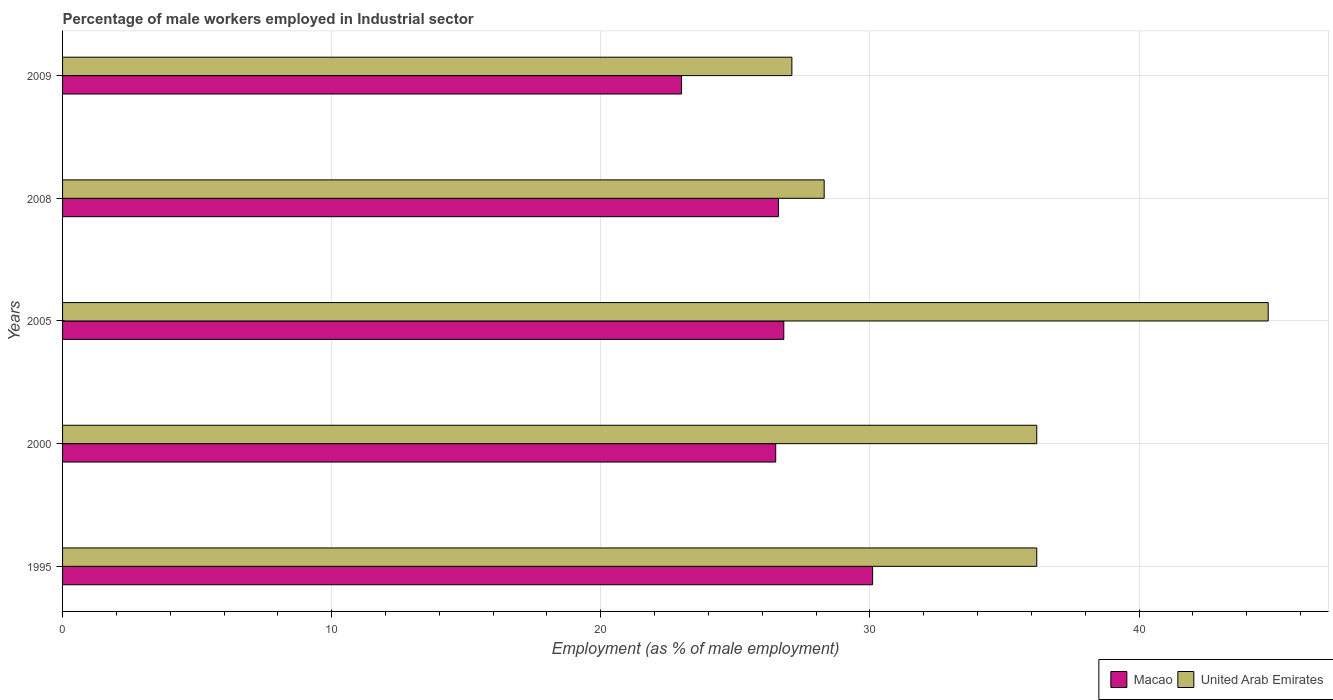How many different coloured bars are there?
Give a very brief answer. 2. How many bars are there on the 1st tick from the bottom?
Offer a very short reply. 2. What is the percentage of male workers employed in Industrial sector in United Arab Emirates in 2000?
Provide a succinct answer. 36.2. Across all years, what is the maximum percentage of male workers employed in Industrial sector in United Arab Emirates?
Keep it short and to the point. 44.8. Across all years, what is the minimum percentage of male workers employed in Industrial sector in Macao?
Your answer should be very brief. 23. In which year was the percentage of male workers employed in Industrial sector in United Arab Emirates maximum?
Offer a terse response. 2005. In which year was the percentage of male workers employed in Industrial sector in United Arab Emirates minimum?
Your answer should be compact. 2009. What is the total percentage of male workers employed in Industrial sector in Macao in the graph?
Offer a terse response. 133. What is the difference between the percentage of male workers employed in Industrial sector in Macao in 2005 and that in 2008?
Provide a short and direct response. 0.2. What is the difference between the percentage of male workers employed in Industrial sector in Macao in 2000 and the percentage of male workers employed in Industrial sector in United Arab Emirates in 2008?
Provide a short and direct response. -1.8. What is the average percentage of male workers employed in Industrial sector in United Arab Emirates per year?
Your answer should be compact. 34.52. In the year 1995, what is the difference between the percentage of male workers employed in Industrial sector in United Arab Emirates and percentage of male workers employed in Industrial sector in Macao?
Offer a very short reply. 6.1. What is the ratio of the percentage of male workers employed in Industrial sector in Macao in 2008 to that in 2009?
Make the answer very short. 1.16. Is the difference between the percentage of male workers employed in Industrial sector in United Arab Emirates in 1995 and 2005 greater than the difference between the percentage of male workers employed in Industrial sector in Macao in 1995 and 2005?
Give a very brief answer. No. What is the difference between the highest and the second highest percentage of male workers employed in Industrial sector in Macao?
Offer a very short reply. 3.3. What is the difference between the highest and the lowest percentage of male workers employed in Industrial sector in United Arab Emirates?
Give a very brief answer. 17.7. In how many years, is the percentage of male workers employed in Industrial sector in United Arab Emirates greater than the average percentage of male workers employed in Industrial sector in United Arab Emirates taken over all years?
Your answer should be very brief. 3. Is the sum of the percentage of male workers employed in Industrial sector in United Arab Emirates in 1995 and 2008 greater than the maximum percentage of male workers employed in Industrial sector in Macao across all years?
Provide a succinct answer. Yes. What does the 2nd bar from the top in 2005 represents?
Offer a terse response. Macao. What does the 1st bar from the bottom in 2000 represents?
Your response must be concise. Macao. How many years are there in the graph?
Give a very brief answer. 5. Are the values on the major ticks of X-axis written in scientific E-notation?
Your response must be concise. No. Does the graph contain grids?
Give a very brief answer. Yes. Where does the legend appear in the graph?
Give a very brief answer. Bottom right. How many legend labels are there?
Give a very brief answer. 2. What is the title of the graph?
Offer a very short reply. Percentage of male workers employed in Industrial sector. Does "Haiti" appear as one of the legend labels in the graph?
Give a very brief answer. No. What is the label or title of the X-axis?
Keep it short and to the point. Employment (as % of male employment). What is the label or title of the Y-axis?
Your answer should be very brief. Years. What is the Employment (as % of male employment) of Macao in 1995?
Offer a terse response. 30.1. What is the Employment (as % of male employment) in United Arab Emirates in 1995?
Keep it short and to the point. 36.2. What is the Employment (as % of male employment) in Macao in 2000?
Your answer should be very brief. 26.5. What is the Employment (as % of male employment) of United Arab Emirates in 2000?
Make the answer very short. 36.2. What is the Employment (as % of male employment) of Macao in 2005?
Provide a succinct answer. 26.8. What is the Employment (as % of male employment) in United Arab Emirates in 2005?
Your answer should be very brief. 44.8. What is the Employment (as % of male employment) in Macao in 2008?
Give a very brief answer. 26.6. What is the Employment (as % of male employment) in United Arab Emirates in 2008?
Your answer should be very brief. 28.3. What is the Employment (as % of male employment) in United Arab Emirates in 2009?
Provide a short and direct response. 27.1. Across all years, what is the maximum Employment (as % of male employment) in Macao?
Keep it short and to the point. 30.1. Across all years, what is the maximum Employment (as % of male employment) in United Arab Emirates?
Keep it short and to the point. 44.8. Across all years, what is the minimum Employment (as % of male employment) of United Arab Emirates?
Provide a succinct answer. 27.1. What is the total Employment (as % of male employment) in Macao in the graph?
Offer a very short reply. 133. What is the total Employment (as % of male employment) of United Arab Emirates in the graph?
Offer a very short reply. 172.6. What is the difference between the Employment (as % of male employment) of United Arab Emirates in 1995 and that in 2000?
Give a very brief answer. 0. What is the difference between the Employment (as % of male employment) in Macao in 1995 and that in 2005?
Keep it short and to the point. 3.3. What is the difference between the Employment (as % of male employment) in United Arab Emirates in 1995 and that in 2009?
Your response must be concise. 9.1. What is the difference between the Employment (as % of male employment) of Macao in 2000 and that in 2009?
Provide a succinct answer. 3.5. What is the difference between the Employment (as % of male employment) of United Arab Emirates in 2000 and that in 2009?
Your answer should be very brief. 9.1. What is the difference between the Employment (as % of male employment) in United Arab Emirates in 2005 and that in 2008?
Keep it short and to the point. 16.5. What is the difference between the Employment (as % of male employment) in United Arab Emirates in 2008 and that in 2009?
Ensure brevity in your answer.  1.2. What is the difference between the Employment (as % of male employment) of Macao in 1995 and the Employment (as % of male employment) of United Arab Emirates in 2005?
Your answer should be compact. -14.7. What is the difference between the Employment (as % of male employment) in Macao in 1995 and the Employment (as % of male employment) in United Arab Emirates in 2009?
Offer a very short reply. 3. What is the difference between the Employment (as % of male employment) in Macao in 2000 and the Employment (as % of male employment) in United Arab Emirates in 2005?
Offer a very short reply. -18.3. What is the difference between the Employment (as % of male employment) of Macao in 2005 and the Employment (as % of male employment) of United Arab Emirates in 2009?
Offer a very short reply. -0.3. What is the average Employment (as % of male employment) of Macao per year?
Your answer should be very brief. 26.6. What is the average Employment (as % of male employment) of United Arab Emirates per year?
Offer a very short reply. 34.52. In the year 1995, what is the difference between the Employment (as % of male employment) of Macao and Employment (as % of male employment) of United Arab Emirates?
Offer a very short reply. -6.1. In the year 2005, what is the difference between the Employment (as % of male employment) in Macao and Employment (as % of male employment) in United Arab Emirates?
Offer a terse response. -18. In the year 2009, what is the difference between the Employment (as % of male employment) in Macao and Employment (as % of male employment) in United Arab Emirates?
Make the answer very short. -4.1. What is the ratio of the Employment (as % of male employment) of Macao in 1995 to that in 2000?
Offer a very short reply. 1.14. What is the ratio of the Employment (as % of male employment) of Macao in 1995 to that in 2005?
Provide a succinct answer. 1.12. What is the ratio of the Employment (as % of male employment) of United Arab Emirates in 1995 to that in 2005?
Ensure brevity in your answer.  0.81. What is the ratio of the Employment (as % of male employment) in Macao in 1995 to that in 2008?
Your answer should be compact. 1.13. What is the ratio of the Employment (as % of male employment) in United Arab Emirates in 1995 to that in 2008?
Provide a short and direct response. 1.28. What is the ratio of the Employment (as % of male employment) of Macao in 1995 to that in 2009?
Offer a very short reply. 1.31. What is the ratio of the Employment (as % of male employment) in United Arab Emirates in 1995 to that in 2009?
Provide a succinct answer. 1.34. What is the ratio of the Employment (as % of male employment) of Macao in 2000 to that in 2005?
Ensure brevity in your answer.  0.99. What is the ratio of the Employment (as % of male employment) of United Arab Emirates in 2000 to that in 2005?
Your response must be concise. 0.81. What is the ratio of the Employment (as % of male employment) in Macao in 2000 to that in 2008?
Make the answer very short. 1. What is the ratio of the Employment (as % of male employment) of United Arab Emirates in 2000 to that in 2008?
Offer a very short reply. 1.28. What is the ratio of the Employment (as % of male employment) of Macao in 2000 to that in 2009?
Provide a succinct answer. 1.15. What is the ratio of the Employment (as % of male employment) of United Arab Emirates in 2000 to that in 2009?
Your response must be concise. 1.34. What is the ratio of the Employment (as % of male employment) in Macao in 2005 to that in 2008?
Keep it short and to the point. 1.01. What is the ratio of the Employment (as % of male employment) of United Arab Emirates in 2005 to that in 2008?
Your answer should be compact. 1.58. What is the ratio of the Employment (as % of male employment) of Macao in 2005 to that in 2009?
Provide a short and direct response. 1.17. What is the ratio of the Employment (as % of male employment) of United Arab Emirates in 2005 to that in 2009?
Make the answer very short. 1.65. What is the ratio of the Employment (as % of male employment) in Macao in 2008 to that in 2009?
Offer a terse response. 1.16. What is the ratio of the Employment (as % of male employment) in United Arab Emirates in 2008 to that in 2009?
Provide a succinct answer. 1.04. What is the difference between the highest and the second highest Employment (as % of male employment) in United Arab Emirates?
Give a very brief answer. 8.6. 